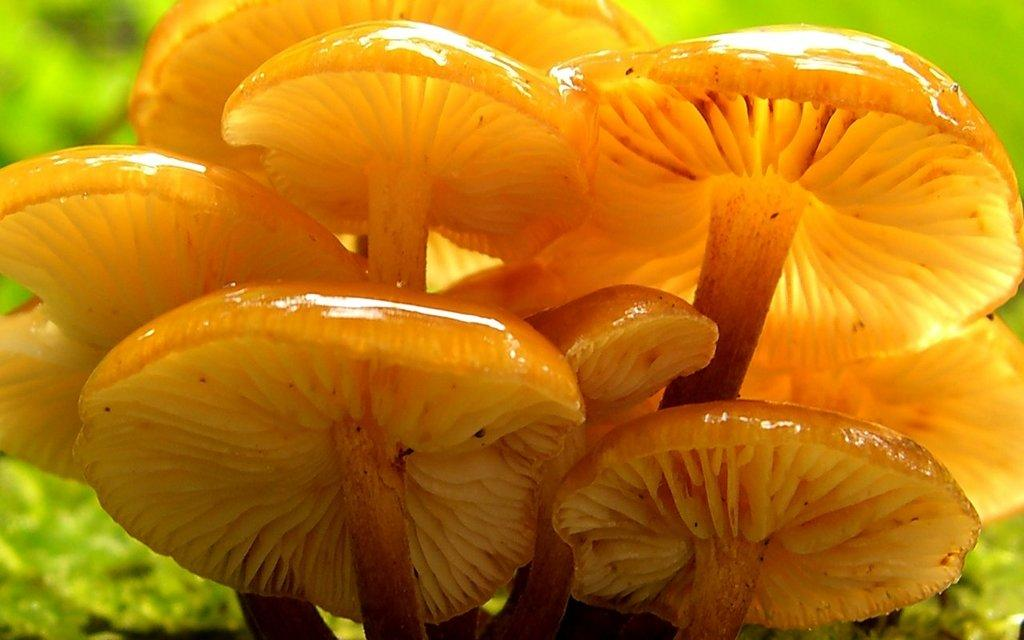What type of fungi can be seen in the image? There are mushrooms in the image. Where are the mushrooms located in the image? The mushrooms are in the center of the image. What color are the mushrooms? The mushrooms are orange in color. Can you hear the sound of a rose in the image? There is no rose present in the image, and therefore no sound can be heard. 